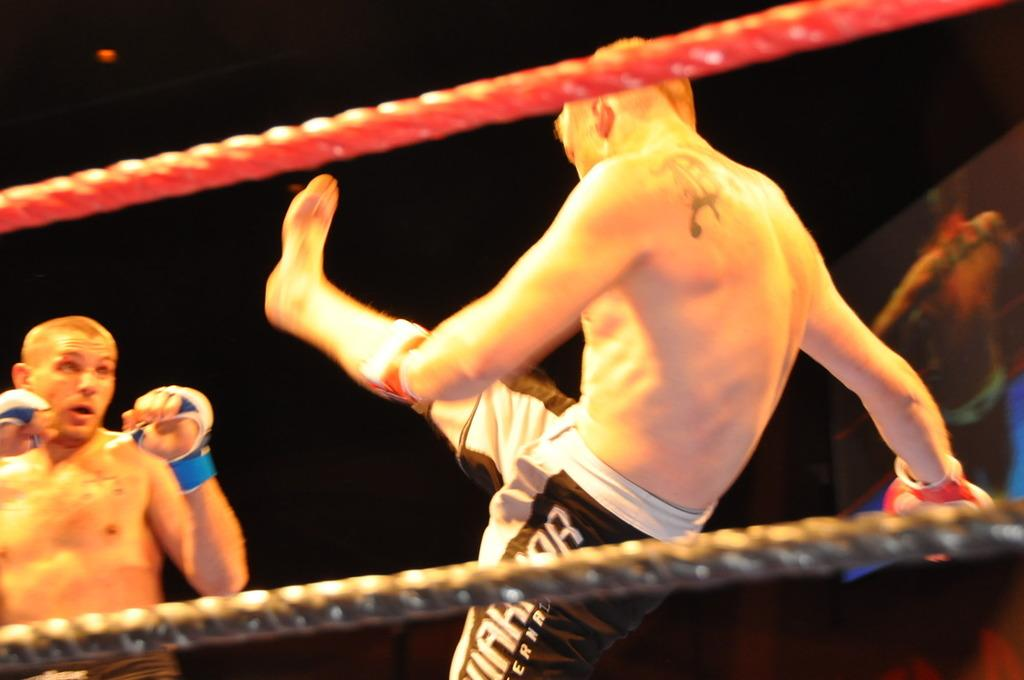How many people are in the image? There are two persons in the image. What are the two persons doing? The two persons are doing wrestling. What can be seen at the top of the image? There is a rope at the top of the image. What can be seen at the bottom of the image? There is a rope at the bottom of the image. What type of sign can be seen near the wrestlers in the image? There is no sign present near the wrestlers in the image. Can you tell me if there is a stream visible in the image? There is no stream visible in the image. 